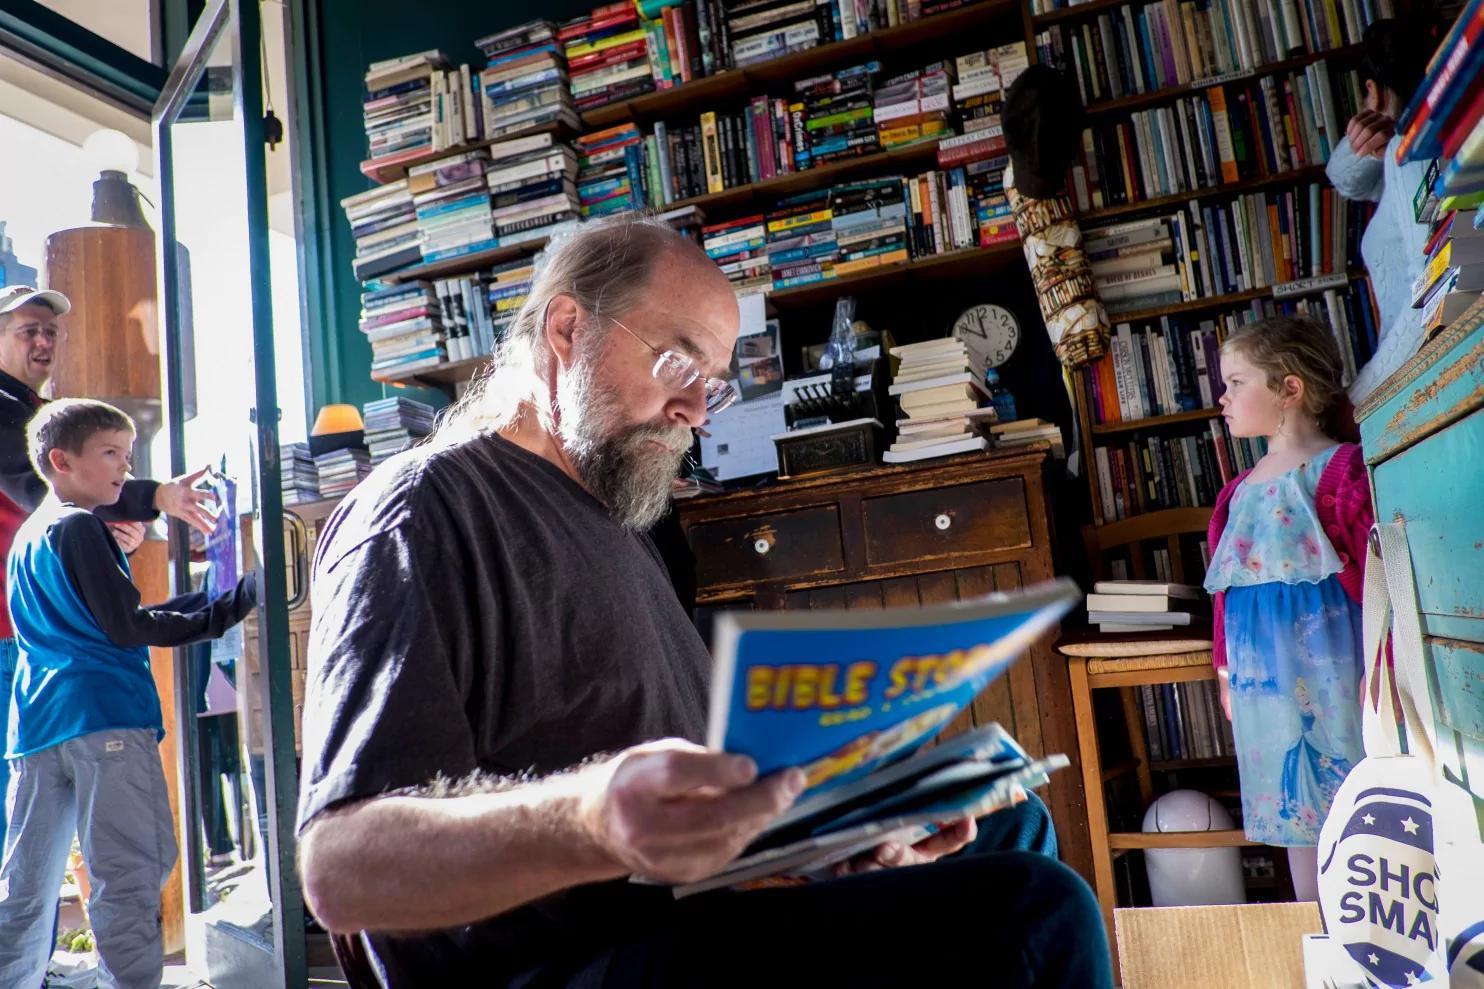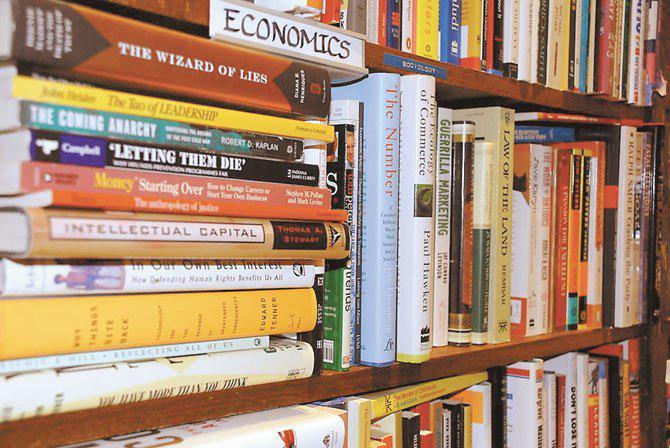The first image is the image on the left, the second image is the image on the right. Evaluate the accuracy of this statement regarding the images: "In one of the images, people are actively browsing the books.". Is it true? Answer yes or no. Yes. The first image is the image on the left, the second image is the image on the right. Considering the images on both sides, is "One image contains more than thirty books and more than two people." valid? Answer yes or no. Yes. 